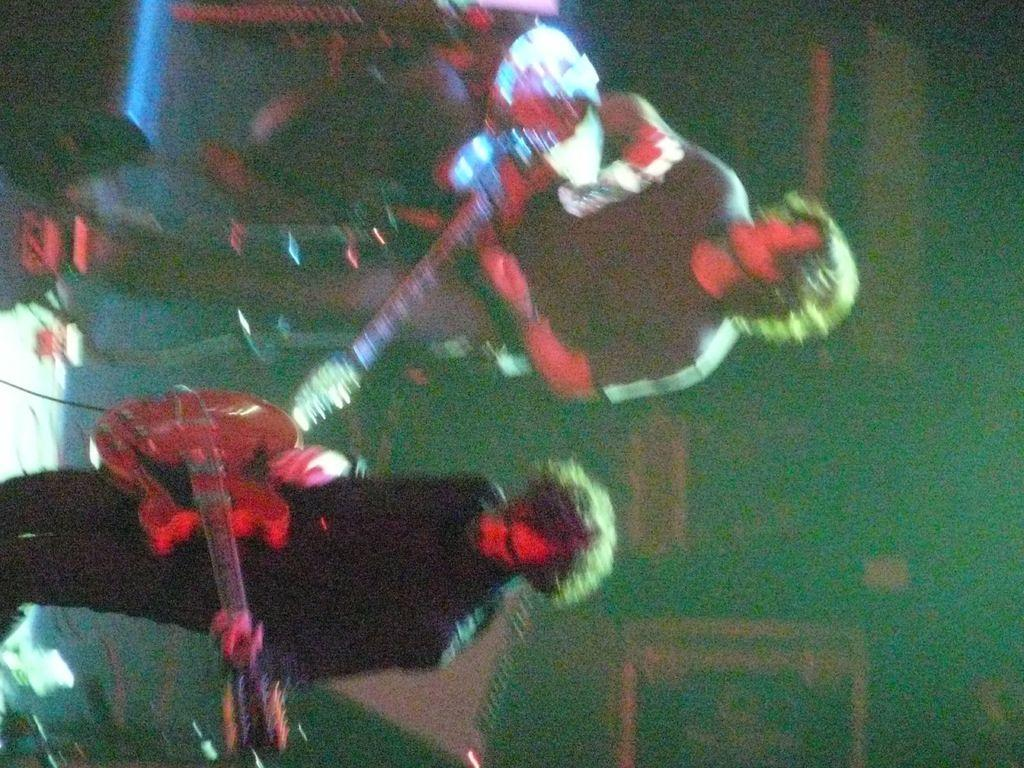How many people are in the image? There are two people in the image. What are the two people doing in the image? The two people are holding musical instruments. What type of yarn is being used by the people in the image? There is no yarn present in the image; the two people are holding musical instruments. 